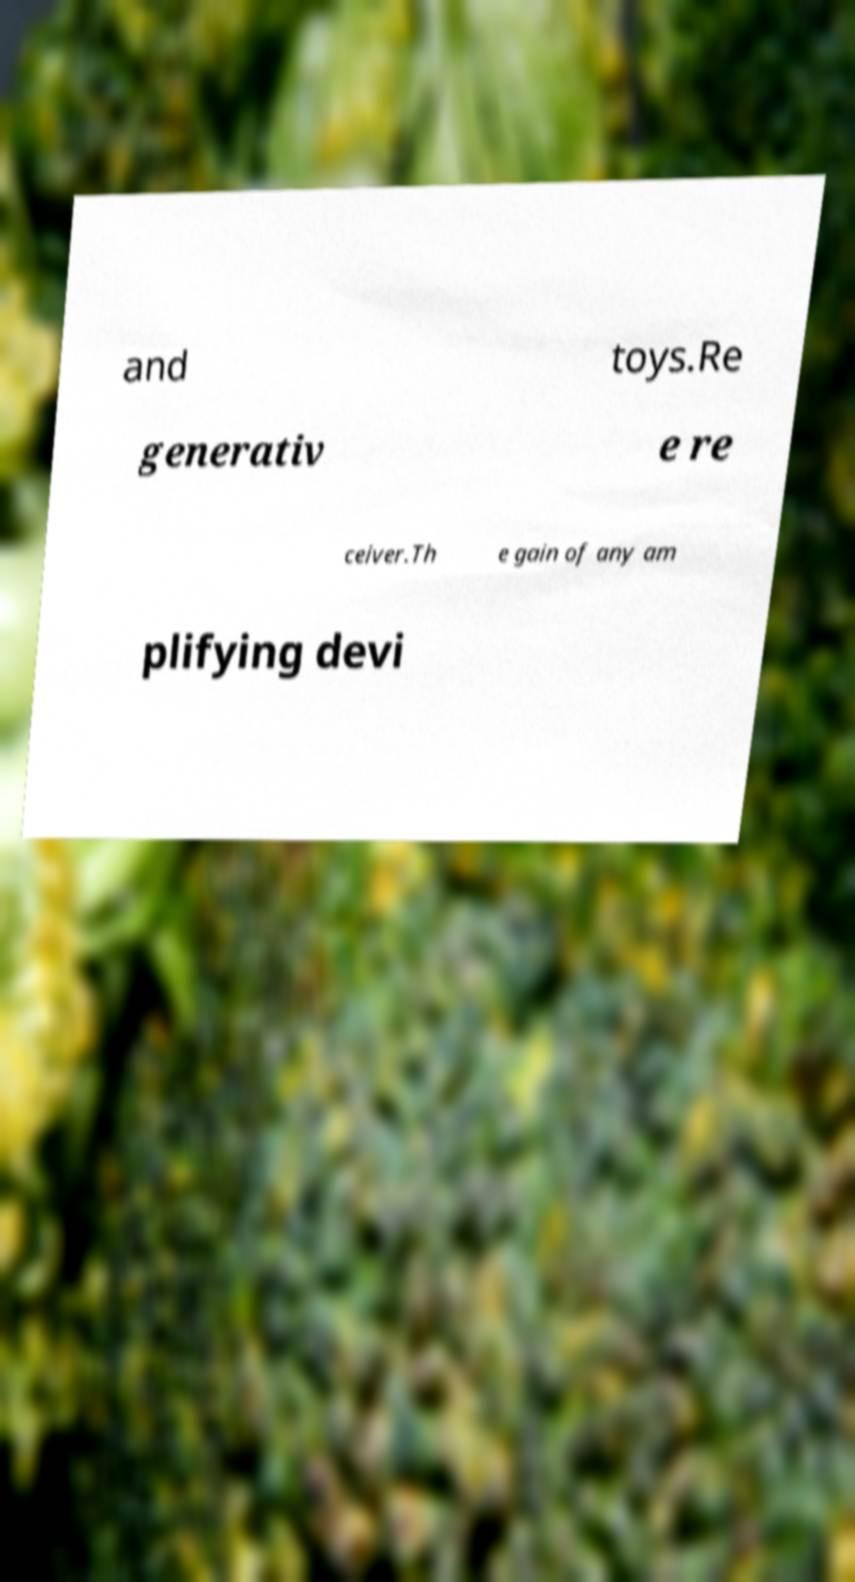Please identify and transcribe the text found in this image. and toys.Re generativ e re ceiver.Th e gain of any am plifying devi 